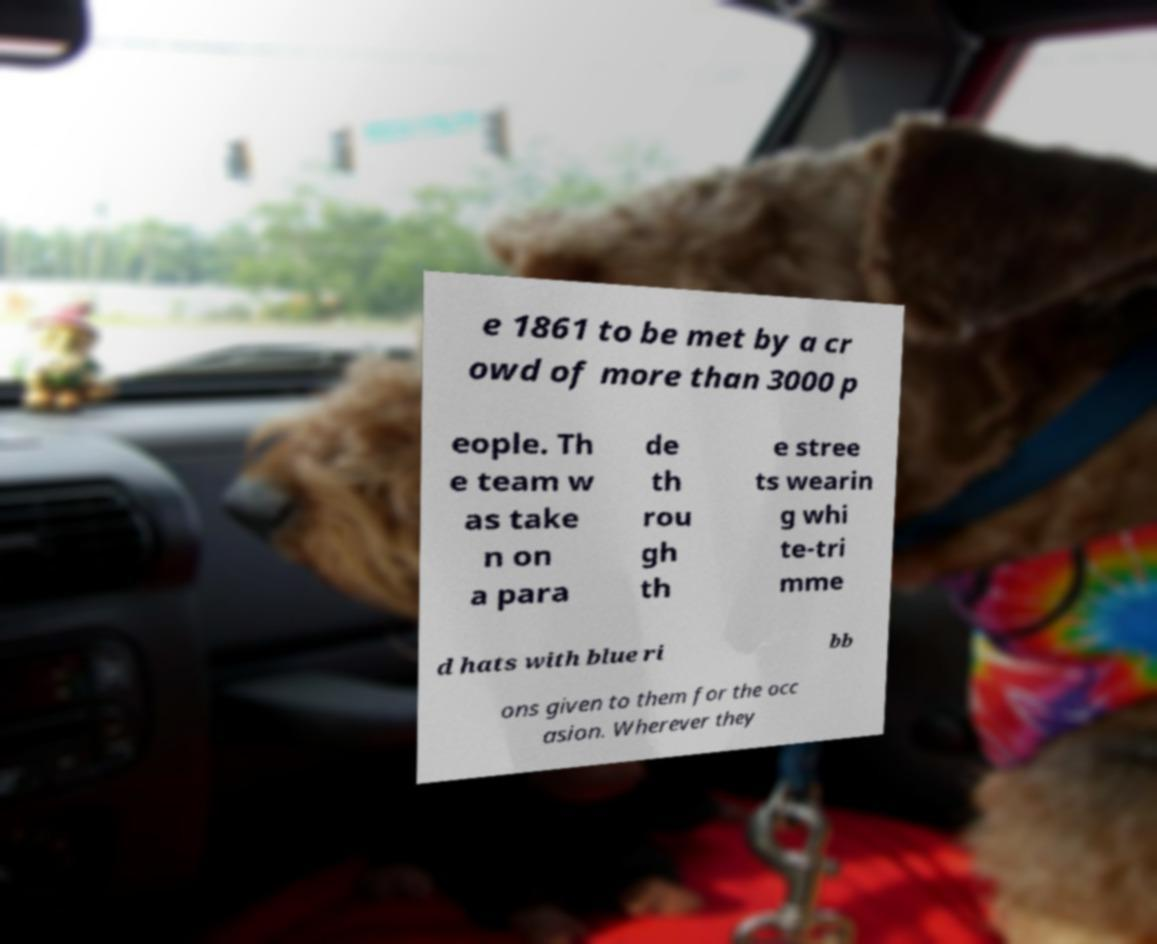Can you accurately transcribe the text from the provided image for me? e 1861 to be met by a cr owd of more than 3000 p eople. Th e team w as take n on a para de th rou gh th e stree ts wearin g whi te-tri mme d hats with blue ri bb ons given to them for the occ asion. Wherever they 